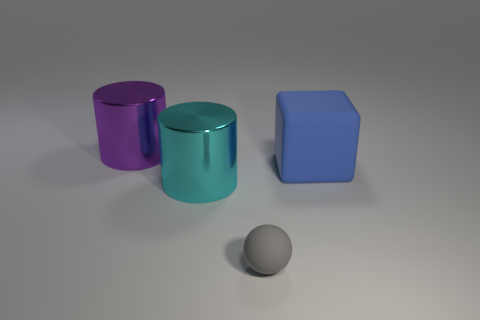Add 4 big cylinders. How many objects exist? 8 Subtract all spheres. How many objects are left? 3 Add 2 spheres. How many spheres exist? 3 Subtract 0 purple balls. How many objects are left? 4 Subtract all large purple matte objects. Subtract all purple cylinders. How many objects are left? 3 Add 4 large purple metallic cylinders. How many large purple metallic cylinders are left? 5 